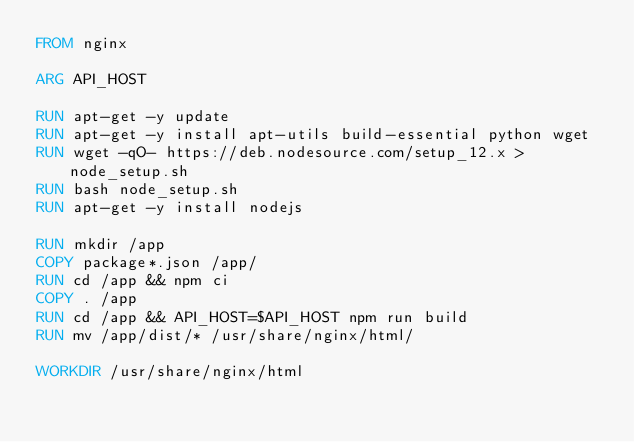Convert code to text. <code><loc_0><loc_0><loc_500><loc_500><_Dockerfile_>FROM nginx

ARG API_HOST

RUN apt-get -y update
RUN apt-get -y install apt-utils build-essential python wget
RUN wget -qO- https://deb.nodesource.com/setup_12.x > node_setup.sh
RUN bash node_setup.sh
RUN apt-get -y install nodejs

RUN mkdir /app
COPY package*.json /app/
RUN cd /app && npm ci
COPY . /app
RUN cd /app && API_HOST=$API_HOST npm run build
RUN mv /app/dist/* /usr/share/nginx/html/

WORKDIR /usr/share/nginx/html

</code> 